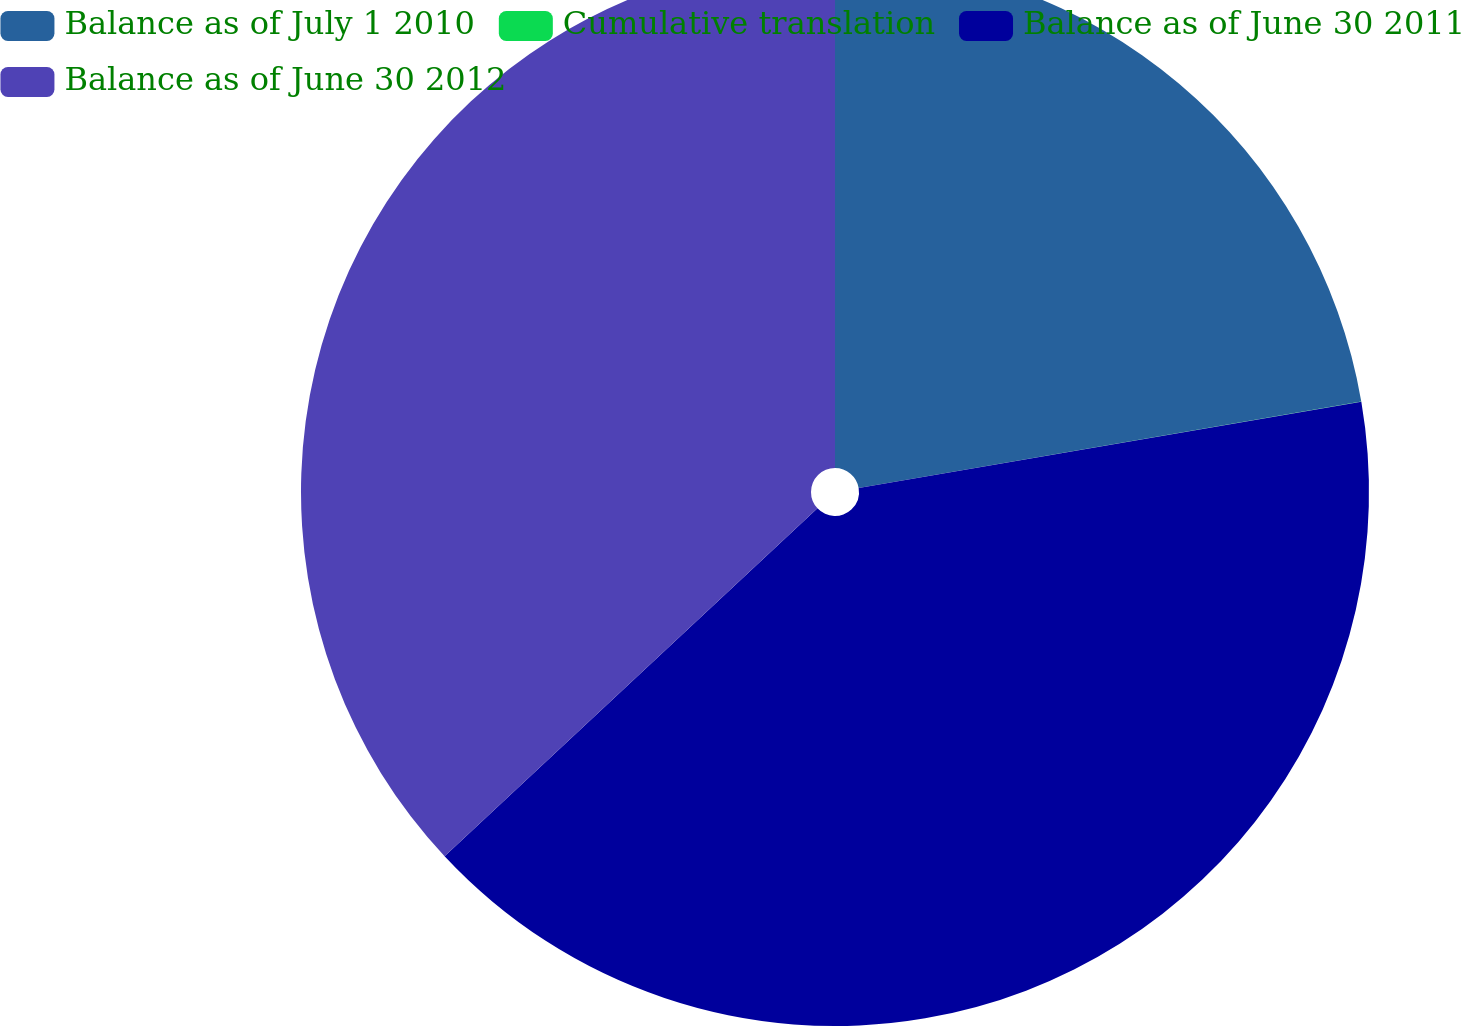Convert chart to OTSL. <chart><loc_0><loc_0><loc_500><loc_500><pie_chart><fcel>Balance as of July 1 2010<fcel>Cumulative translation<fcel>Balance as of June 30 2011<fcel>Balance as of June 30 2012<nl><fcel>22.29%<fcel>0.01%<fcel>40.75%<fcel>36.95%<nl></chart> 